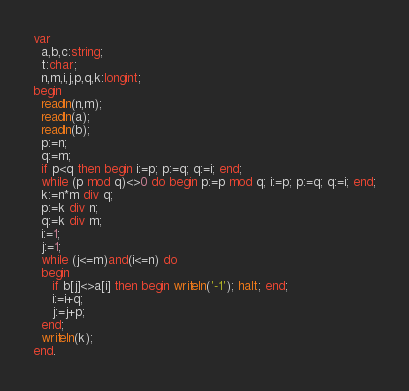Convert code to text. <code><loc_0><loc_0><loc_500><loc_500><_Pascal_>var
  a,b,c:string;
  t:char;
  n,m,i,j,p,q,k:longint;
begin
  readln(n,m);
  readln(a);
  readln(b);
  p:=n;
  q:=m;
  if p<q then begin i:=p; p:=q; q:=i; end;
  while (p mod q)<>0 do begin p:=p mod q; i:=p; p:=q; q:=i; end;
  k:=n*m div q;
  p:=k div n;
  q:=k div m;
  i:=1;
  j:=1;
  while (j<=m)and(i<=n) do
  begin
	 if b[j]<>a[i] then begin writeln('-1'); halt; end;
     i:=i+q;
	 j:=j+p;
  end;
  writeln(k);
end.</code> 